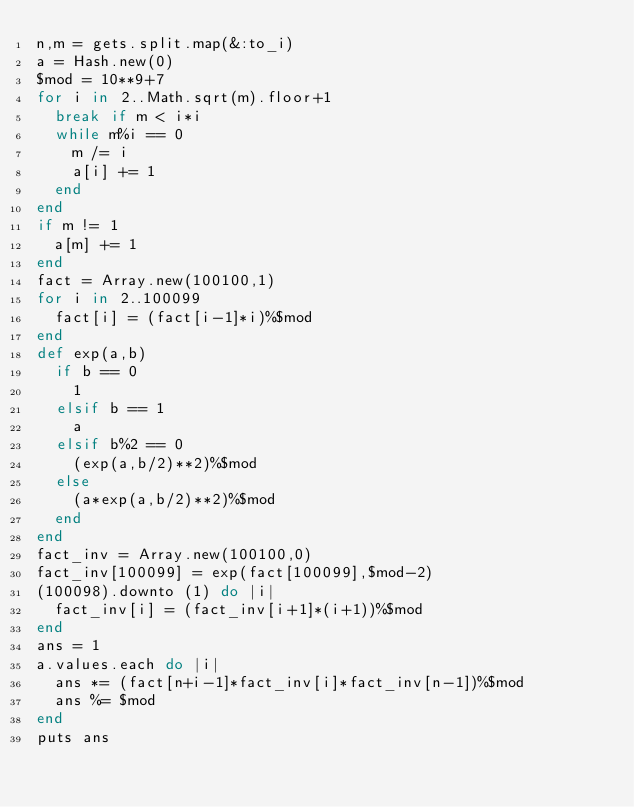Convert code to text. <code><loc_0><loc_0><loc_500><loc_500><_Ruby_>n,m = gets.split.map(&:to_i)
a = Hash.new(0)
$mod = 10**9+7
for i in 2..Math.sqrt(m).floor+1
  break if m < i*i
  while m%i == 0
    m /= i
    a[i] += 1
  end
end
if m != 1
  a[m] += 1
end
fact = Array.new(100100,1)
for i in 2..100099
  fact[i] = (fact[i-1]*i)%$mod
end
def exp(a,b)
  if b == 0
    1
  elsif b == 1
    a
  elsif b%2 == 0
    (exp(a,b/2)**2)%$mod
  else
    (a*exp(a,b/2)**2)%$mod
  end
end
fact_inv = Array.new(100100,0)
fact_inv[100099] = exp(fact[100099],$mod-2)
(100098).downto (1) do |i|
  fact_inv[i] = (fact_inv[i+1]*(i+1))%$mod
end
ans = 1
a.values.each do |i|
  ans *= (fact[n+i-1]*fact_inv[i]*fact_inv[n-1])%$mod
  ans %= $mod
end
puts ans</code> 